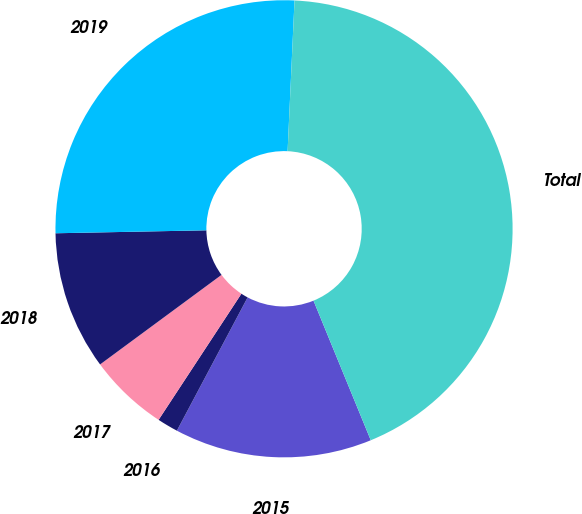Convert chart. <chart><loc_0><loc_0><loc_500><loc_500><pie_chart><fcel>2015<fcel>2016<fcel>2017<fcel>2018<fcel>2019<fcel>Total<nl><fcel>13.96%<fcel>1.48%<fcel>5.64%<fcel>9.8%<fcel>26.04%<fcel>43.07%<nl></chart> 